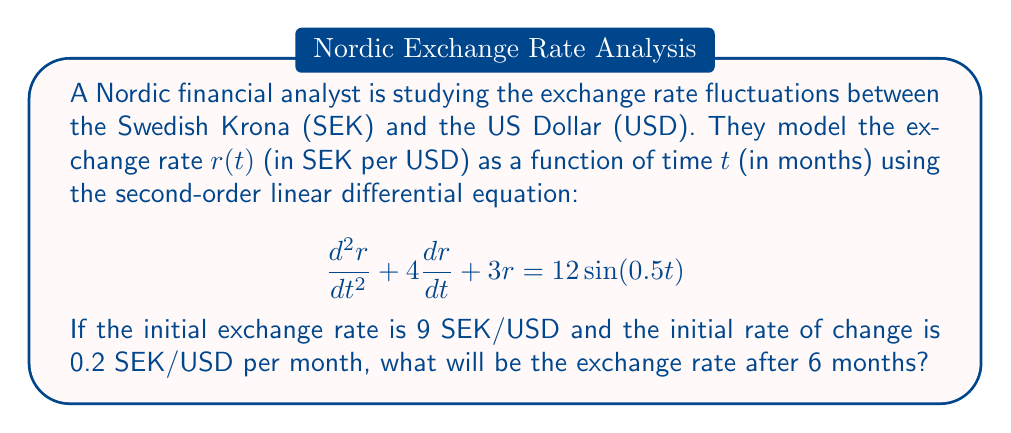Can you solve this math problem? To solve this problem, we need to find the general solution to the differential equation and then apply the initial conditions. Here's the step-by-step process:

1) The homogeneous solution:
   The characteristic equation is $m^2 + 4m + 3 = 0$
   Solving this: $m = -1$ or $m = -3$
   So, the homogeneous solution is $r_h(t) = c_1e^{-t} + c_2e^{-3t}$

2) The particular solution:
   We can assume a solution of the form $r_p(t) = A\sin(0.5t) + B\cos(0.5t)$
   Substituting this into the original equation and solving for A and B gives:
   $r_p(t) = \frac{12}{11.25}\sin(0.5t) - \frac{8}{11.25}\cos(0.5t)$

3) The general solution is the sum of the homogeneous and particular solutions:
   $r(t) = c_1e^{-t} + c_2e^{-3t} + \frac{12}{11.25}\sin(0.5t) - \frac{8}{11.25}\cos(0.5t)$

4) Apply the initial conditions:
   $r(0) = 9$ and $r'(0) = 0.2$
   
   From $r(0) = 9$:
   $c_1 + c_2 - \frac{8}{11.25} = 9$
   
   From $r'(0) = 0.2$:
   $-c_1 - 3c_2 + \frac{6}{11.25} = 0.2$

5) Solve these equations to get:
   $c_1 \approx 8.8889$ and $c_2 \approx 0.8222$

6) The final solution is:
   $r(t) = 8.8889e^{-t} + 0.8222e^{-3t} + \frac{12}{11.25}\sin(0.5t) - \frac{8}{11.25}\cos(0.5t)$

7) To find the exchange rate after 6 months, calculate $r(6)$:
   $r(6) = 8.8889e^{-6} + 0.8222e^{-18} + \frac{12}{11.25}\sin(3) - \frac{8}{11.25}\cos(3)$
Answer: The exchange rate after 6 months will be approximately 8.7133 SEK/USD. 